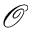<formula> <loc_0><loc_0><loc_500><loc_500>\mathcal { O }</formula> 